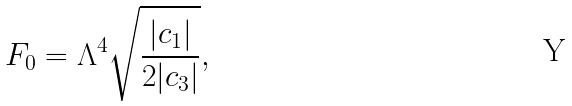<formula> <loc_0><loc_0><loc_500><loc_500>F _ { 0 } = \Lambda ^ { 4 } \sqrt { \frac { | c _ { 1 } | } { 2 | c _ { 3 } | } } ,</formula> 